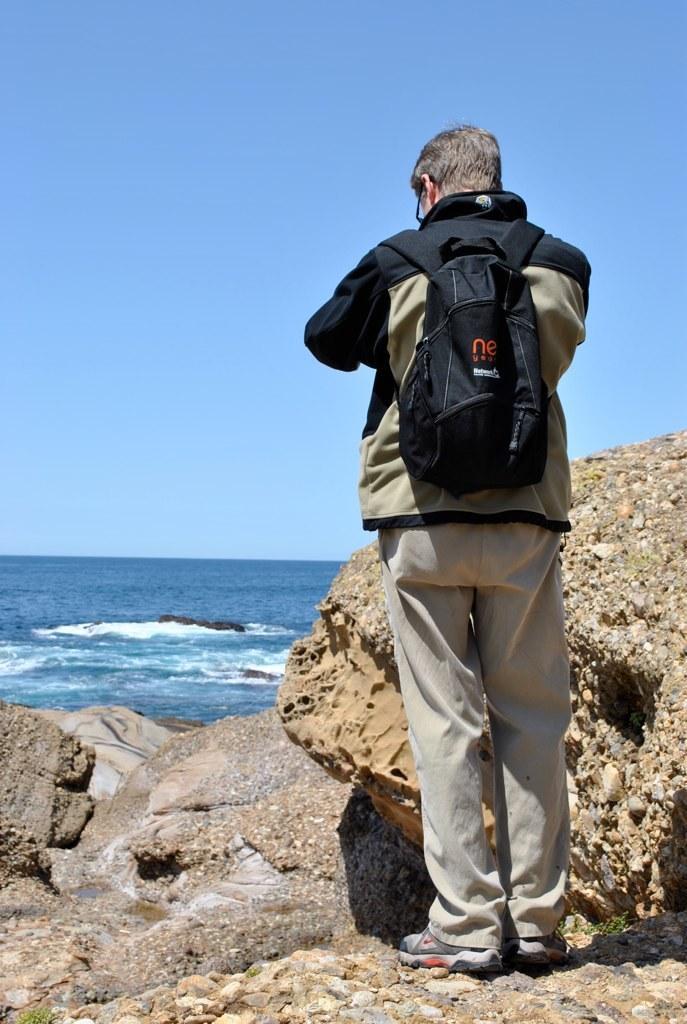Describe this image in one or two sentences. In this picture a man standing on his wearing a backpack, in front of him we can find a ocean. 